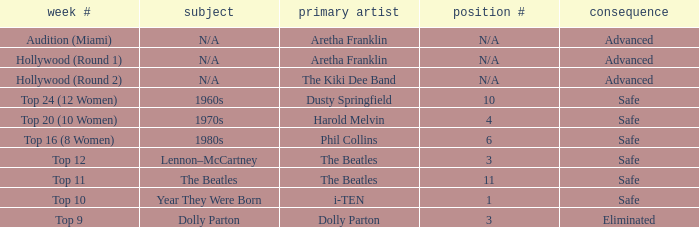What is the original artist that has 11 as the order number? The Beatles. 